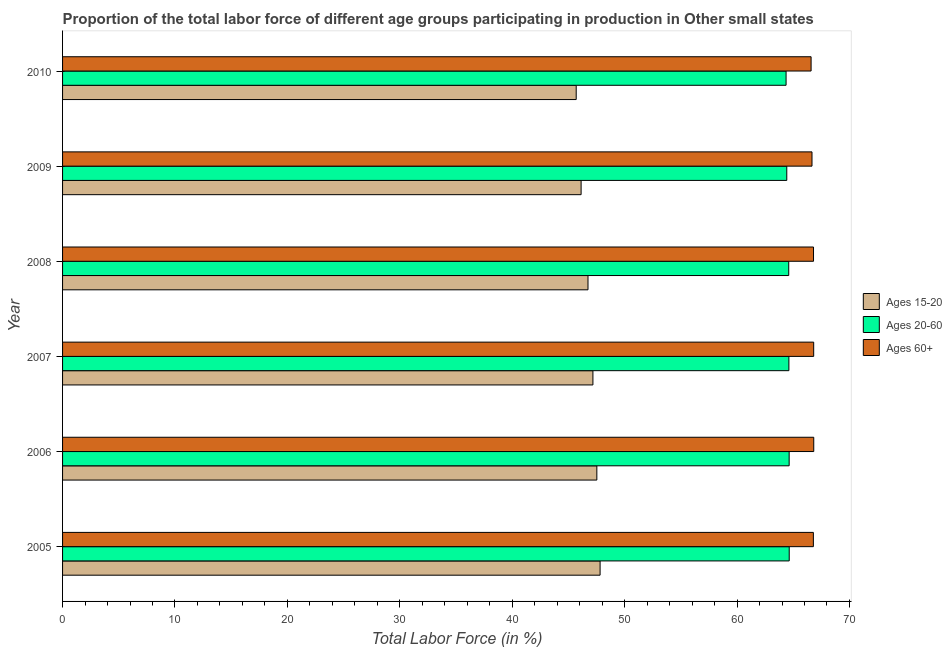How many different coloured bars are there?
Keep it short and to the point. 3. How many groups of bars are there?
Your answer should be compact. 6. Are the number of bars per tick equal to the number of legend labels?
Ensure brevity in your answer.  Yes. Are the number of bars on each tick of the Y-axis equal?
Provide a short and direct response. Yes. In how many cases, is the number of bars for a given year not equal to the number of legend labels?
Your answer should be compact. 0. What is the percentage of labor force within the age group 15-20 in 2006?
Offer a terse response. 47.53. Across all years, what is the maximum percentage of labor force within the age group 15-20?
Your response must be concise. 47.82. Across all years, what is the minimum percentage of labor force within the age group 20-60?
Provide a short and direct response. 64.36. In which year was the percentage of labor force within the age group 15-20 maximum?
Your answer should be compact. 2005. In which year was the percentage of labor force within the age group 15-20 minimum?
Offer a very short reply. 2010. What is the total percentage of labor force within the age group 15-20 in the graph?
Ensure brevity in your answer.  281.08. What is the difference between the percentage of labor force above age 60 in 2007 and that in 2010?
Make the answer very short. 0.23. What is the difference between the percentage of labor force within the age group 20-60 in 2010 and the percentage of labor force above age 60 in 2005?
Keep it short and to the point. -2.43. What is the average percentage of labor force within the age group 20-60 per year?
Provide a short and direct response. 64.55. In the year 2009, what is the difference between the percentage of labor force within the age group 20-60 and percentage of labor force within the age group 15-20?
Offer a very short reply. 18.3. In how many years, is the percentage of labor force above age 60 greater than 30 %?
Offer a very short reply. 6. Is the percentage of labor force within the age group 15-20 in 2005 less than that in 2006?
Offer a terse response. No. Is the difference between the percentage of labor force above age 60 in 2007 and 2008 greater than the difference between the percentage of labor force within the age group 20-60 in 2007 and 2008?
Ensure brevity in your answer.  Yes. What is the difference between the highest and the second highest percentage of labor force above age 60?
Keep it short and to the point. 0.01. What is the difference between the highest and the lowest percentage of labor force within the age group 15-20?
Offer a very short reply. 2.13. In how many years, is the percentage of labor force within the age group 15-20 greater than the average percentage of labor force within the age group 15-20 taken over all years?
Provide a short and direct response. 3. What does the 1st bar from the top in 2008 represents?
Offer a terse response. Ages 60+. What does the 1st bar from the bottom in 2010 represents?
Keep it short and to the point. Ages 15-20. Is it the case that in every year, the sum of the percentage of labor force within the age group 15-20 and percentage of labor force within the age group 20-60 is greater than the percentage of labor force above age 60?
Your response must be concise. Yes. Are all the bars in the graph horizontal?
Your response must be concise. Yes. Does the graph contain any zero values?
Keep it short and to the point. No. What is the title of the graph?
Give a very brief answer. Proportion of the total labor force of different age groups participating in production in Other small states. Does "Domestic" appear as one of the legend labels in the graph?
Offer a terse response. No. What is the label or title of the Y-axis?
Give a very brief answer. Year. What is the Total Labor Force (in %) in Ages 15-20 in 2005?
Your answer should be very brief. 47.82. What is the Total Labor Force (in %) of Ages 20-60 in 2005?
Ensure brevity in your answer.  64.64. What is the Total Labor Force (in %) of Ages 60+ in 2005?
Your answer should be compact. 66.79. What is the Total Labor Force (in %) in Ages 15-20 in 2006?
Your answer should be very brief. 47.53. What is the Total Labor Force (in %) of Ages 20-60 in 2006?
Your answer should be very brief. 64.64. What is the Total Labor Force (in %) of Ages 60+ in 2006?
Offer a very short reply. 66.82. What is the Total Labor Force (in %) of Ages 15-20 in 2007?
Provide a short and direct response. 47.18. What is the Total Labor Force (in %) in Ages 20-60 in 2007?
Your answer should be very brief. 64.61. What is the Total Labor Force (in %) in Ages 60+ in 2007?
Offer a very short reply. 66.82. What is the Total Labor Force (in %) of Ages 15-20 in 2008?
Make the answer very short. 46.74. What is the Total Labor Force (in %) in Ages 20-60 in 2008?
Keep it short and to the point. 64.6. What is the Total Labor Force (in %) in Ages 60+ in 2008?
Your answer should be very brief. 66.8. What is the Total Labor Force (in %) of Ages 15-20 in 2009?
Give a very brief answer. 46.13. What is the Total Labor Force (in %) in Ages 20-60 in 2009?
Give a very brief answer. 64.42. What is the Total Labor Force (in %) in Ages 60+ in 2009?
Your response must be concise. 66.67. What is the Total Labor Force (in %) in Ages 15-20 in 2010?
Your response must be concise. 45.69. What is the Total Labor Force (in %) of Ages 20-60 in 2010?
Your response must be concise. 64.36. What is the Total Labor Force (in %) in Ages 60+ in 2010?
Keep it short and to the point. 66.59. Across all years, what is the maximum Total Labor Force (in %) of Ages 15-20?
Offer a very short reply. 47.82. Across all years, what is the maximum Total Labor Force (in %) of Ages 20-60?
Provide a succinct answer. 64.64. Across all years, what is the maximum Total Labor Force (in %) in Ages 60+?
Give a very brief answer. 66.82. Across all years, what is the minimum Total Labor Force (in %) of Ages 15-20?
Provide a succinct answer. 45.69. Across all years, what is the minimum Total Labor Force (in %) in Ages 20-60?
Offer a very short reply. 64.36. Across all years, what is the minimum Total Labor Force (in %) of Ages 60+?
Provide a succinct answer. 66.59. What is the total Total Labor Force (in %) of Ages 15-20 in the graph?
Give a very brief answer. 281.08. What is the total Total Labor Force (in %) of Ages 20-60 in the graph?
Your answer should be very brief. 387.27. What is the total Total Labor Force (in %) in Ages 60+ in the graph?
Make the answer very short. 400.49. What is the difference between the Total Labor Force (in %) of Ages 15-20 in 2005 and that in 2006?
Offer a very short reply. 0.29. What is the difference between the Total Labor Force (in %) in Ages 20-60 in 2005 and that in 2006?
Make the answer very short. 0.01. What is the difference between the Total Labor Force (in %) of Ages 60+ in 2005 and that in 2006?
Keep it short and to the point. -0.03. What is the difference between the Total Labor Force (in %) of Ages 15-20 in 2005 and that in 2007?
Your answer should be very brief. 0.64. What is the difference between the Total Labor Force (in %) in Ages 20-60 in 2005 and that in 2007?
Make the answer very short. 0.03. What is the difference between the Total Labor Force (in %) of Ages 60+ in 2005 and that in 2007?
Provide a short and direct response. -0.03. What is the difference between the Total Labor Force (in %) in Ages 15-20 in 2005 and that in 2008?
Provide a short and direct response. 1.08. What is the difference between the Total Labor Force (in %) of Ages 20-60 in 2005 and that in 2008?
Your answer should be very brief. 0.04. What is the difference between the Total Labor Force (in %) in Ages 60+ in 2005 and that in 2008?
Make the answer very short. -0.01. What is the difference between the Total Labor Force (in %) in Ages 15-20 in 2005 and that in 2009?
Give a very brief answer. 1.69. What is the difference between the Total Labor Force (in %) of Ages 20-60 in 2005 and that in 2009?
Provide a succinct answer. 0.22. What is the difference between the Total Labor Force (in %) in Ages 60+ in 2005 and that in 2009?
Your response must be concise. 0.12. What is the difference between the Total Labor Force (in %) of Ages 15-20 in 2005 and that in 2010?
Give a very brief answer. 2.13. What is the difference between the Total Labor Force (in %) of Ages 20-60 in 2005 and that in 2010?
Provide a short and direct response. 0.28. What is the difference between the Total Labor Force (in %) of Ages 60+ in 2005 and that in 2010?
Provide a short and direct response. 0.2. What is the difference between the Total Labor Force (in %) in Ages 15-20 in 2006 and that in 2007?
Keep it short and to the point. 0.35. What is the difference between the Total Labor Force (in %) in Ages 20-60 in 2006 and that in 2007?
Provide a succinct answer. 0.02. What is the difference between the Total Labor Force (in %) of Ages 60+ in 2006 and that in 2007?
Provide a short and direct response. 0.01. What is the difference between the Total Labor Force (in %) of Ages 15-20 in 2006 and that in 2008?
Your answer should be compact. 0.79. What is the difference between the Total Labor Force (in %) in Ages 20-60 in 2006 and that in 2008?
Your response must be concise. 0.04. What is the difference between the Total Labor Force (in %) in Ages 60+ in 2006 and that in 2008?
Offer a very short reply. 0.02. What is the difference between the Total Labor Force (in %) of Ages 15-20 in 2006 and that in 2009?
Offer a very short reply. 1.4. What is the difference between the Total Labor Force (in %) of Ages 20-60 in 2006 and that in 2009?
Make the answer very short. 0.21. What is the difference between the Total Labor Force (in %) in Ages 60+ in 2006 and that in 2009?
Your response must be concise. 0.16. What is the difference between the Total Labor Force (in %) in Ages 15-20 in 2006 and that in 2010?
Keep it short and to the point. 1.84. What is the difference between the Total Labor Force (in %) in Ages 20-60 in 2006 and that in 2010?
Give a very brief answer. 0.27. What is the difference between the Total Labor Force (in %) in Ages 60+ in 2006 and that in 2010?
Your answer should be compact. 0.24. What is the difference between the Total Labor Force (in %) of Ages 15-20 in 2007 and that in 2008?
Give a very brief answer. 0.44. What is the difference between the Total Labor Force (in %) in Ages 20-60 in 2007 and that in 2008?
Your answer should be compact. 0.01. What is the difference between the Total Labor Force (in %) of Ages 60+ in 2007 and that in 2008?
Provide a succinct answer. 0.02. What is the difference between the Total Labor Force (in %) of Ages 15-20 in 2007 and that in 2009?
Offer a terse response. 1.05. What is the difference between the Total Labor Force (in %) of Ages 20-60 in 2007 and that in 2009?
Offer a terse response. 0.19. What is the difference between the Total Labor Force (in %) of Ages 60+ in 2007 and that in 2009?
Provide a short and direct response. 0.15. What is the difference between the Total Labor Force (in %) in Ages 15-20 in 2007 and that in 2010?
Provide a succinct answer. 1.49. What is the difference between the Total Labor Force (in %) in Ages 20-60 in 2007 and that in 2010?
Your response must be concise. 0.25. What is the difference between the Total Labor Force (in %) of Ages 60+ in 2007 and that in 2010?
Make the answer very short. 0.23. What is the difference between the Total Labor Force (in %) in Ages 15-20 in 2008 and that in 2009?
Your answer should be very brief. 0.61. What is the difference between the Total Labor Force (in %) in Ages 20-60 in 2008 and that in 2009?
Your answer should be compact. 0.17. What is the difference between the Total Labor Force (in %) of Ages 60+ in 2008 and that in 2009?
Keep it short and to the point. 0.14. What is the difference between the Total Labor Force (in %) in Ages 15-20 in 2008 and that in 2010?
Your answer should be very brief. 1.05. What is the difference between the Total Labor Force (in %) of Ages 20-60 in 2008 and that in 2010?
Ensure brevity in your answer.  0.24. What is the difference between the Total Labor Force (in %) of Ages 60+ in 2008 and that in 2010?
Your answer should be compact. 0.22. What is the difference between the Total Labor Force (in %) of Ages 15-20 in 2009 and that in 2010?
Ensure brevity in your answer.  0.44. What is the difference between the Total Labor Force (in %) of Ages 20-60 in 2009 and that in 2010?
Make the answer very short. 0.06. What is the difference between the Total Labor Force (in %) in Ages 60+ in 2009 and that in 2010?
Keep it short and to the point. 0.08. What is the difference between the Total Labor Force (in %) of Ages 15-20 in 2005 and the Total Labor Force (in %) of Ages 20-60 in 2006?
Keep it short and to the point. -16.82. What is the difference between the Total Labor Force (in %) of Ages 15-20 in 2005 and the Total Labor Force (in %) of Ages 60+ in 2006?
Your answer should be compact. -19.01. What is the difference between the Total Labor Force (in %) in Ages 20-60 in 2005 and the Total Labor Force (in %) in Ages 60+ in 2006?
Offer a terse response. -2.18. What is the difference between the Total Labor Force (in %) in Ages 15-20 in 2005 and the Total Labor Force (in %) in Ages 20-60 in 2007?
Offer a terse response. -16.79. What is the difference between the Total Labor Force (in %) of Ages 15-20 in 2005 and the Total Labor Force (in %) of Ages 60+ in 2007?
Make the answer very short. -19. What is the difference between the Total Labor Force (in %) of Ages 20-60 in 2005 and the Total Labor Force (in %) of Ages 60+ in 2007?
Your response must be concise. -2.18. What is the difference between the Total Labor Force (in %) of Ages 15-20 in 2005 and the Total Labor Force (in %) of Ages 20-60 in 2008?
Offer a terse response. -16.78. What is the difference between the Total Labor Force (in %) in Ages 15-20 in 2005 and the Total Labor Force (in %) in Ages 60+ in 2008?
Ensure brevity in your answer.  -18.98. What is the difference between the Total Labor Force (in %) of Ages 20-60 in 2005 and the Total Labor Force (in %) of Ages 60+ in 2008?
Your answer should be compact. -2.16. What is the difference between the Total Labor Force (in %) of Ages 15-20 in 2005 and the Total Labor Force (in %) of Ages 20-60 in 2009?
Make the answer very short. -16.61. What is the difference between the Total Labor Force (in %) in Ages 15-20 in 2005 and the Total Labor Force (in %) in Ages 60+ in 2009?
Your response must be concise. -18.85. What is the difference between the Total Labor Force (in %) of Ages 20-60 in 2005 and the Total Labor Force (in %) of Ages 60+ in 2009?
Keep it short and to the point. -2.03. What is the difference between the Total Labor Force (in %) of Ages 15-20 in 2005 and the Total Labor Force (in %) of Ages 20-60 in 2010?
Keep it short and to the point. -16.54. What is the difference between the Total Labor Force (in %) in Ages 15-20 in 2005 and the Total Labor Force (in %) in Ages 60+ in 2010?
Ensure brevity in your answer.  -18.77. What is the difference between the Total Labor Force (in %) in Ages 20-60 in 2005 and the Total Labor Force (in %) in Ages 60+ in 2010?
Your answer should be compact. -1.95. What is the difference between the Total Labor Force (in %) in Ages 15-20 in 2006 and the Total Labor Force (in %) in Ages 20-60 in 2007?
Give a very brief answer. -17.08. What is the difference between the Total Labor Force (in %) in Ages 15-20 in 2006 and the Total Labor Force (in %) in Ages 60+ in 2007?
Provide a short and direct response. -19.29. What is the difference between the Total Labor Force (in %) of Ages 20-60 in 2006 and the Total Labor Force (in %) of Ages 60+ in 2007?
Provide a short and direct response. -2.18. What is the difference between the Total Labor Force (in %) of Ages 15-20 in 2006 and the Total Labor Force (in %) of Ages 20-60 in 2008?
Give a very brief answer. -17.07. What is the difference between the Total Labor Force (in %) in Ages 15-20 in 2006 and the Total Labor Force (in %) in Ages 60+ in 2008?
Give a very brief answer. -19.27. What is the difference between the Total Labor Force (in %) of Ages 20-60 in 2006 and the Total Labor Force (in %) of Ages 60+ in 2008?
Offer a very short reply. -2.17. What is the difference between the Total Labor Force (in %) of Ages 15-20 in 2006 and the Total Labor Force (in %) of Ages 20-60 in 2009?
Give a very brief answer. -16.9. What is the difference between the Total Labor Force (in %) in Ages 15-20 in 2006 and the Total Labor Force (in %) in Ages 60+ in 2009?
Ensure brevity in your answer.  -19.14. What is the difference between the Total Labor Force (in %) in Ages 20-60 in 2006 and the Total Labor Force (in %) in Ages 60+ in 2009?
Your response must be concise. -2.03. What is the difference between the Total Labor Force (in %) in Ages 15-20 in 2006 and the Total Labor Force (in %) in Ages 20-60 in 2010?
Offer a very short reply. -16.83. What is the difference between the Total Labor Force (in %) in Ages 15-20 in 2006 and the Total Labor Force (in %) in Ages 60+ in 2010?
Provide a succinct answer. -19.06. What is the difference between the Total Labor Force (in %) of Ages 20-60 in 2006 and the Total Labor Force (in %) of Ages 60+ in 2010?
Give a very brief answer. -1.95. What is the difference between the Total Labor Force (in %) of Ages 15-20 in 2007 and the Total Labor Force (in %) of Ages 20-60 in 2008?
Offer a very short reply. -17.42. What is the difference between the Total Labor Force (in %) in Ages 15-20 in 2007 and the Total Labor Force (in %) in Ages 60+ in 2008?
Provide a short and direct response. -19.62. What is the difference between the Total Labor Force (in %) of Ages 20-60 in 2007 and the Total Labor Force (in %) of Ages 60+ in 2008?
Ensure brevity in your answer.  -2.19. What is the difference between the Total Labor Force (in %) in Ages 15-20 in 2007 and the Total Labor Force (in %) in Ages 20-60 in 2009?
Provide a short and direct response. -17.25. What is the difference between the Total Labor Force (in %) in Ages 15-20 in 2007 and the Total Labor Force (in %) in Ages 60+ in 2009?
Your response must be concise. -19.49. What is the difference between the Total Labor Force (in %) of Ages 20-60 in 2007 and the Total Labor Force (in %) of Ages 60+ in 2009?
Your answer should be compact. -2.05. What is the difference between the Total Labor Force (in %) of Ages 15-20 in 2007 and the Total Labor Force (in %) of Ages 20-60 in 2010?
Keep it short and to the point. -17.18. What is the difference between the Total Labor Force (in %) of Ages 15-20 in 2007 and the Total Labor Force (in %) of Ages 60+ in 2010?
Your response must be concise. -19.41. What is the difference between the Total Labor Force (in %) of Ages 20-60 in 2007 and the Total Labor Force (in %) of Ages 60+ in 2010?
Make the answer very short. -1.97. What is the difference between the Total Labor Force (in %) of Ages 15-20 in 2008 and the Total Labor Force (in %) of Ages 20-60 in 2009?
Your answer should be very brief. -17.68. What is the difference between the Total Labor Force (in %) in Ages 15-20 in 2008 and the Total Labor Force (in %) in Ages 60+ in 2009?
Offer a very short reply. -19.93. What is the difference between the Total Labor Force (in %) in Ages 20-60 in 2008 and the Total Labor Force (in %) in Ages 60+ in 2009?
Provide a succinct answer. -2.07. What is the difference between the Total Labor Force (in %) in Ages 15-20 in 2008 and the Total Labor Force (in %) in Ages 20-60 in 2010?
Provide a short and direct response. -17.62. What is the difference between the Total Labor Force (in %) of Ages 15-20 in 2008 and the Total Labor Force (in %) of Ages 60+ in 2010?
Provide a short and direct response. -19.85. What is the difference between the Total Labor Force (in %) of Ages 20-60 in 2008 and the Total Labor Force (in %) of Ages 60+ in 2010?
Your response must be concise. -1.99. What is the difference between the Total Labor Force (in %) of Ages 15-20 in 2009 and the Total Labor Force (in %) of Ages 20-60 in 2010?
Your response must be concise. -18.23. What is the difference between the Total Labor Force (in %) in Ages 15-20 in 2009 and the Total Labor Force (in %) in Ages 60+ in 2010?
Provide a succinct answer. -20.46. What is the difference between the Total Labor Force (in %) in Ages 20-60 in 2009 and the Total Labor Force (in %) in Ages 60+ in 2010?
Your answer should be compact. -2.16. What is the average Total Labor Force (in %) in Ages 15-20 per year?
Make the answer very short. 46.85. What is the average Total Labor Force (in %) of Ages 20-60 per year?
Your answer should be compact. 64.55. What is the average Total Labor Force (in %) of Ages 60+ per year?
Your answer should be very brief. 66.75. In the year 2005, what is the difference between the Total Labor Force (in %) of Ages 15-20 and Total Labor Force (in %) of Ages 20-60?
Offer a terse response. -16.82. In the year 2005, what is the difference between the Total Labor Force (in %) in Ages 15-20 and Total Labor Force (in %) in Ages 60+?
Your response must be concise. -18.97. In the year 2005, what is the difference between the Total Labor Force (in %) in Ages 20-60 and Total Labor Force (in %) in Ages 60+?
Your answer should be very brief. -2.15. In the year 2006, what is the difference between the Total Labor Force (in %) of Ages 15-20 and Total Labor Force (in %) of Ages 20-60?
Keep it short and to the point. -17.11. In the year 2006, what is the difference between the Total Labor Force (in %) of Ages 15-20 and Total Labor Force (in %) of Ages 60+?
Provide a short and direct response. -19.3. In the year 2006, what is the difference between the Total Labor Force (in %) of Ages 20-60 and Total Labor Force (in %) of Ages 60+?
Provide a short and direct response. -2.19. In the year 2007, what is the difference between the Total Labor Force (in %) of Ages 15-20 and Total Labor Force (in %) of Ages 20-60?
Your answer should be compact. -17.43. In the year 2007, what is the difference between the Total Labor Force (in %) of Ages 15-20 and Total Labor Force (in %) of Ages 60+?
Make the answer very short. -19.64. In the year 2007, what is the difference between the Total Labor Force (in %) in Ages 20-60 and Total Labor Force (in %) in Ages 60+?
Your response must be concise. -2.21. In the year 2008, what is the difference between the Total Labor Force (in %) in Ages 15-20 and Total Labor Force (in %) in Ages 20-60?
Your answer should be compact. -17.86. In the year 2008, what is the difference between the Total Labor Force (in %) in Ages 15-20 and Total Labor Force (in %) in Ages 60+?
Keep it short and to the point. -20.06. In the year 2008, what is the difference between the Total Labor Force (in %) of Ages 20-60 and Total Labor Force (in %) of Ages 60+?
Offer a very short reply. -2.2. In the year 2009, what is the difference between the Total Labor Force (in %) in Ages 15-20 and Total Labor Force (in %) in Ages 20-60?
Your response must be concise. -18.3. In the year 2009, what is the difference between the Total Labor Force (in %) of Ages 15-20 and Total Labor Force (in %) of Ages 60+?
Provide a succinct answer. -20.54. In the year 2009, what is the difference between the Total Labor Force (in %) in Ages 20-60 and Total Labor Force (in %) in Ages 60+?
Offer a very short reply. -2.24. In the year 2010, what is the difference between the Total Labor Force (in %) of Ages 15-20 and Total Labor Force (in %) of Ages 20-60?
Make the answer very short. -18.67. In the year 2010, what is the difference between the Total Labor Force (in %) in Ages 15-20 and Total Labor Force (in %) in Ages 60+?
Provide a short and direct response. -20.9. In the year 2010, what is the difference between the Total Labor Force (in %) of Ages 20-60 and Total Labor Force (in %) of Ages 60+?
Provide a short and direct response. -2.23. What is the ratio of the Total Labor Force (in %) of Ages 15-20 in 2005 to that in 2006?
Give a very brief answer. 1.01. What is the ratio of the Total Labor Force (in %) in Ages 15-20 in 2005 to that in 2007?
Keep it short and to the point. 1.01. What is the ratio of the Total Labor Force (in %) of Ages 20-60 in 2005 to that in 2007?
Provide a succinct answer. 1. What is the ratio of the Total Labor Force (in %) in Ages 15-20 in 2005 to that in 2008?
Provide a short and direct response. 1.02. What is the ratio of the Total Labor Force (in %) in Ages 15-20 in 2005 to that in 2009?
Keep it short and to the point. 1.04. What is the ratio of the Total Labor Force (in %) in Ages 20-60 in 2005 to that in 2009?
Provide a succinct answer. 1. What is the ratio of the Total Labor Force (in %) in Ages 60+ in 2005 to that in 2009?
Your response must be concise. 1. What is the ratio of the Total Labor Force (in %) of Ages 15-20 in 2005 to that in 2010?
Keep it short and to the point. 1.05. What is the ratio of the Total Labor Force (in %) of Ages 15-20 in 2006 to that in 2007?
Give a very brief answer. 1.01. What is the ratio of the Total Labor Force (in %) of Ages 20-60 in 2006 to that in 2007?
Ensure brevity in your answer.  1. What is the ratio of the Total Labor Force (in %) in Ages 15-20 in 2006 to that in 2008?
Give a very brief answer. 1.02. What is the ratio of the Total Labor Force (in %) in Ages 20-60 in 2006 to that in 2008?
Your answer should be compact. 1. What is the ratio of the Total Labor Force (in %) of Ages 60+ in 2006 to that in 2008?
Offer a terse response. 1. What is the ratio of the Total Labor Force (in %) of Ages 15-20 in 2006 to that in 2009?
Offer a very short reply. 1.03. What is the ratio of the Total Labor Force (in %) in Ages 15-20 in 2006 to that in 2010?
Provide a short and direct response. 1.04. What is the ratio of the Total Labor Force (in %) of Ages 20-60 in 2006 to that in 2010?
Your answer should be very brief. 1. What is the ratio of the Total Labor Force (in %) of Ages 60+ in 2006 to that in 2010?
Give a very brief answer. 1. What is the ratio of the Total Labor Force (in %) in Ages 15-20 in 2007 to that in 2008?
Make the answer very short. 1.01. What is the ratio of the Total Labor Force (in %) in Ages 60+ in 2007 to that in 2008?
Make the answer very short. 1. What is the ratio of the Total Labor Force (in %) in Ages 15-20 in 2007 to that in 2009?
Provide a short and direct response. 1.02. What is the ratio of the Total Labor Force (in %) in Ages 20-60 in 2007 to that in 2009?
Provide a short and direct response. 1. What is the ratio of the Total Labor Force (in %) of Ages 15-20 in 2007 to that in 2010?
Make the answer very short. 1.03. What is the ratio of the Total Labor Force (in %) in Ages 20-60 in 2007 to that in 2010?
Make the answer very short. 1. What is the ratio of the Total Labor Force (in %) in Ages 60+ in 2007 to that in 2010?
Your answer should be compact. 1. What is the ratio of the Total Labor Force (in %) in Ages 15-20 in 2008 to that in 2009?
Keep it short and to the point. 1.01. What is the ratio of the Total Labor Force (in %) of Ages 20-60 in 2008 to that in 2010?
Ensure brevity in your answer.  1. What is the ratio of the Total Labor Force (in %) of Ages 60+ in 2008 to that in 2010?
Provide a short and direct response. 1. What is the ratio of the Total Labor Force (in %) of Ages 15-20 in 2009 to that in 2010?
Provide a short and direct response. 1.01. What is the ratio of the Total Labor Force (in %) in Ages 20-60 in 2009 to that in 2010?
Your response must be concise. 1. What is the ratio of the Total Labor Force (in %) in Ages 60+ in 2009 to that in 2010?
Make the answer very short. 1. What is the difference between the highest and the second highest Total Labor Force (in %) of Ages 15-20?
Offer a very short reply. 0.29. What is the difference between the highest and the second highest Total Labor Force (in %) in Ages 20-60?
Ensure brevity in your answer.  0.01. What is the difference between the highest and the second highest Total Labor Force (in %) in Ages 60+?
Offer a very short reply. 0.01. What is the difference between the highest and the lowest Total Labor Force (in %) of Ages 15-20?
Provide a short and direct response. 2.13. What is the difference between the highest and the lowest Total Labor Force (in %) in Ages 20-60?
Ensure brevity in your answer.  0.28. What is the difference between the highest and the lowest Total Labor Force (in %) in Ages 60+?
Make the answer very short. 0.24. 